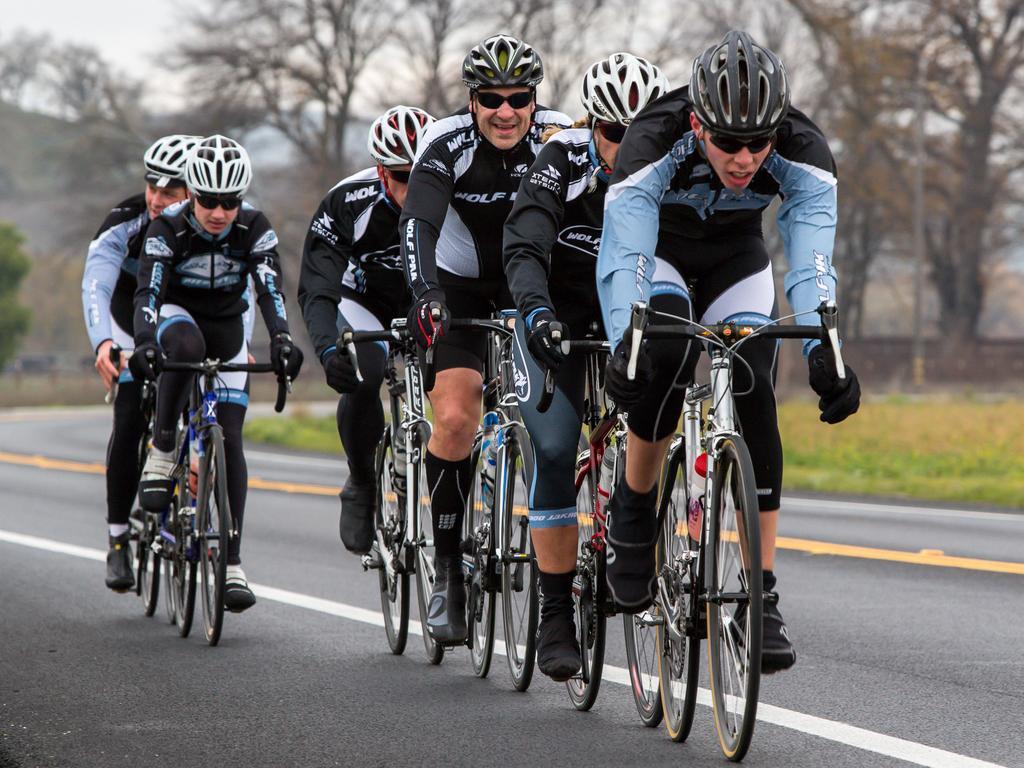How would you summarize this image in a sentence or two? In this picture there are group of people riding bicycles on the road. At the back there is a mountain and there are trees and there is a pole. At the top there is sky. At the bottom there is a road and there is grass. 